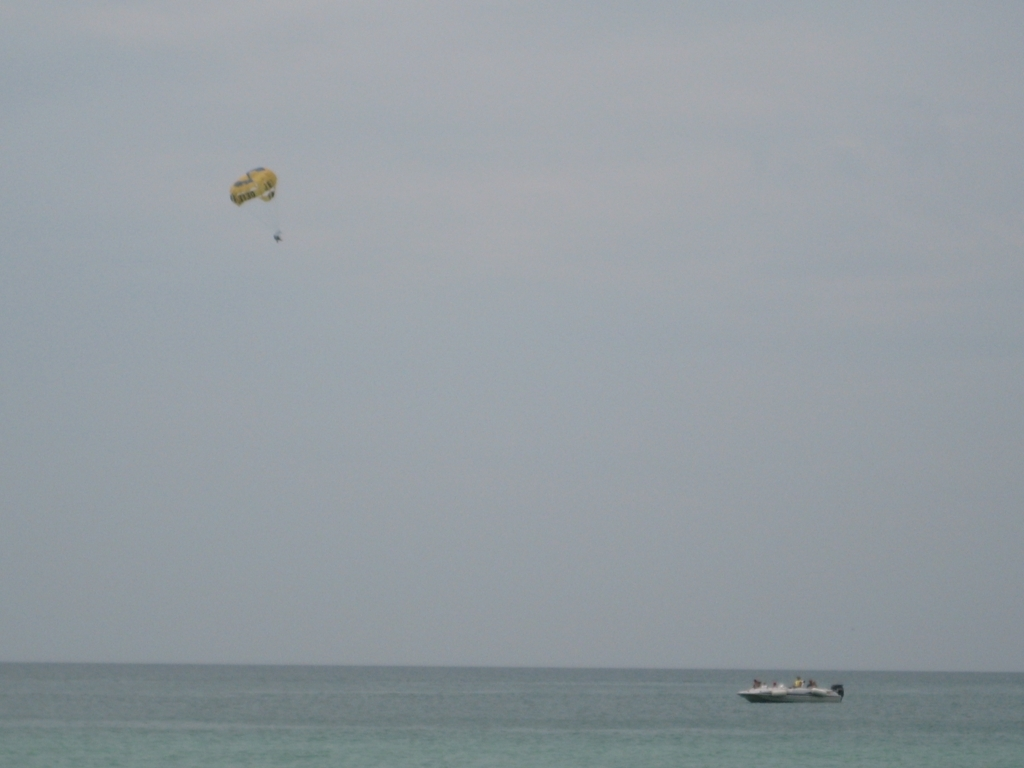What emotions does this scene evoke, and how could that feeling be made more potent in the photograph? This scene evokes a sense of tranquility and solitude, brought about by the vastness of the sea and the solitary figure of the parasailer. To make this feeling more potent, the photographer could employ techniques like rule of thirds to frame the parasailer in a manner that accentuates their isolation. Additionally, waiting for a moment where the lighting dynamically interacts with the subjects – for instance, light breaking through clouds to highlight the parasailer – could amplify the emotional impact of the photograph. 